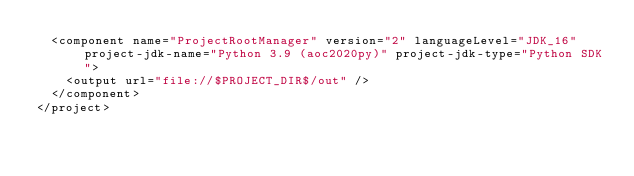Convert code to text. <code><loc_0><loc_0><loc_500><loc_500><_XML_>  <component name="ProjectRootManager" version="2" languageLevel="JDK_16" project-jdk-name="Python 3.9 (aoc2020py)" project-jdk-type="Python SDK">
    <output url="file://$PROJECT_DIR$/out" />
  </component>
</project></code> 